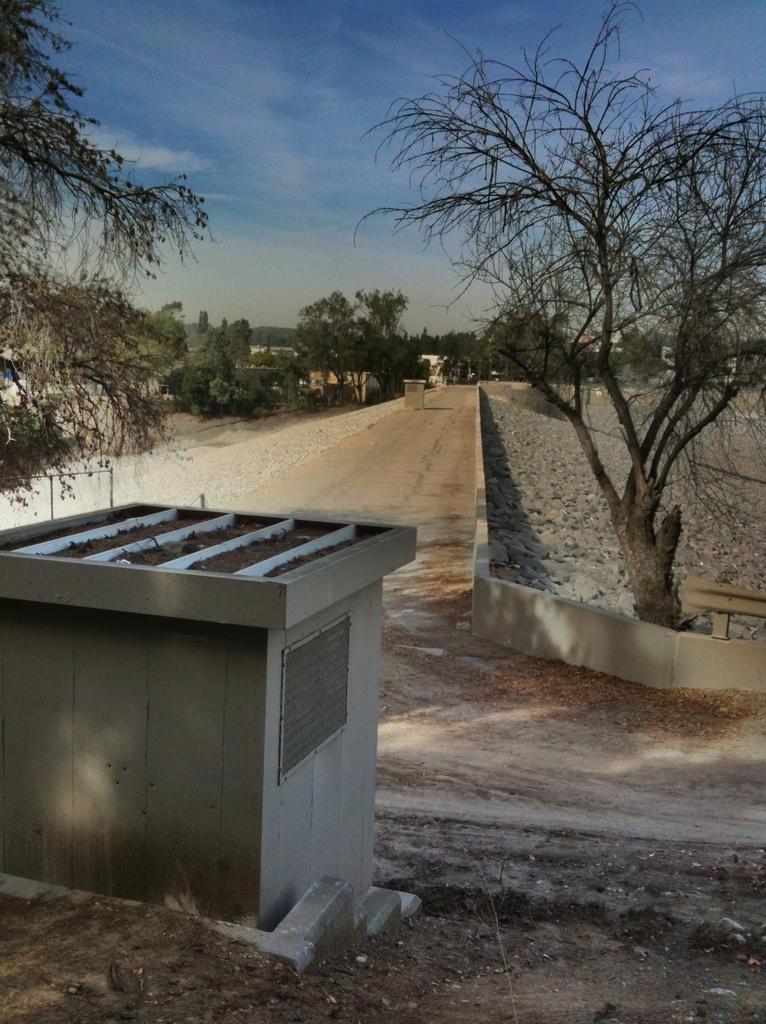Could you give a brief overview of what you see in this image? In this image I can see a cement box,trees,few stones and buildings. The sky is in blue and white color. 